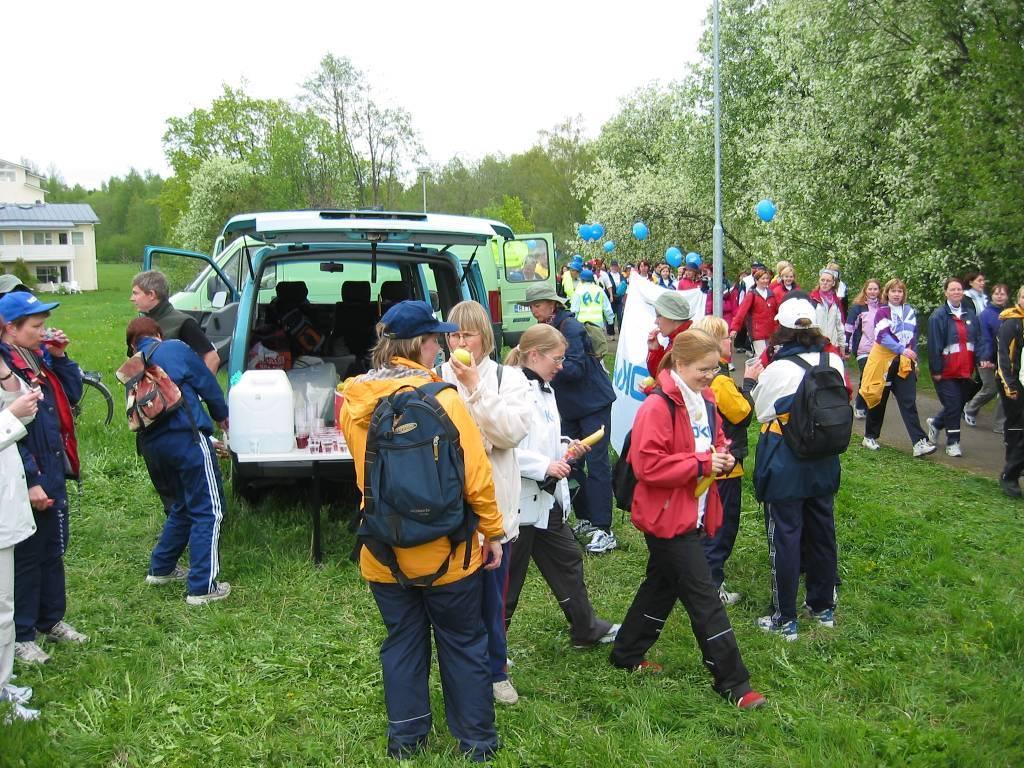In one or two sentences, can you explain what this image depicts? In this image we can see a motor vehicle on the ground and person standing on ground and road. In the background we can see poles, buildings, trees and sky. 